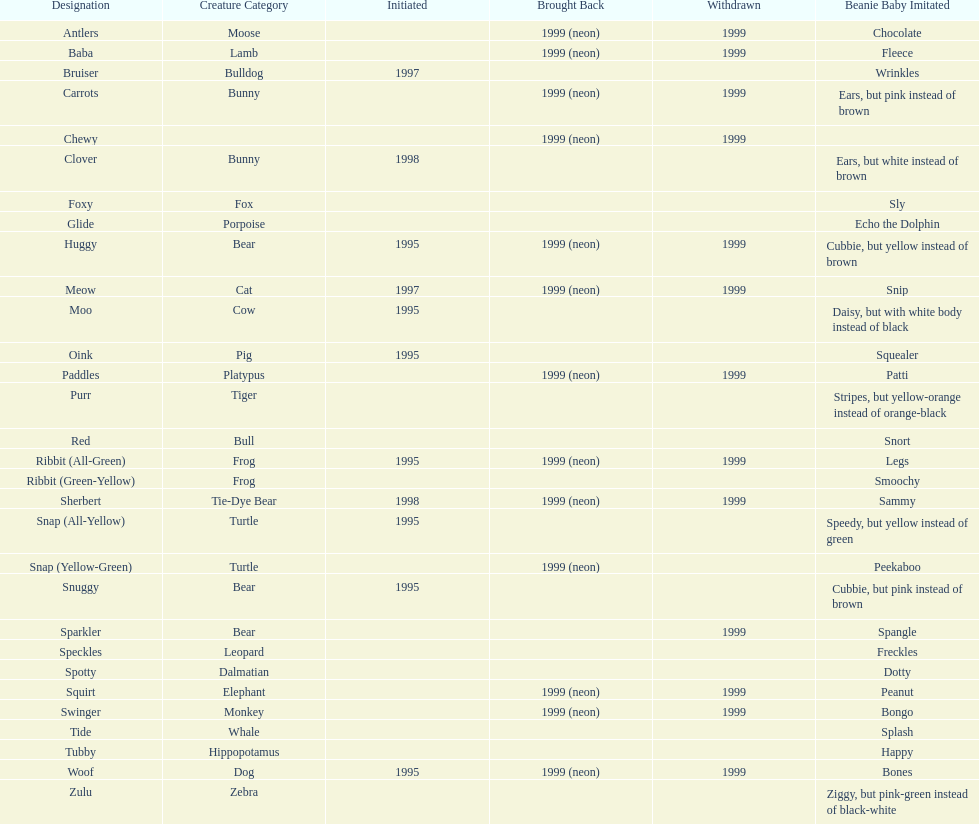Name the only pillow pal that is a dalmatian. Spotty. 